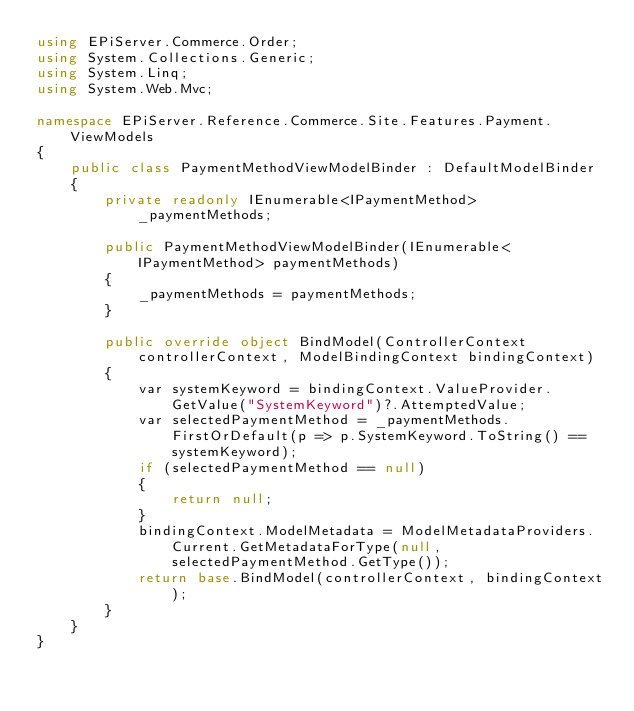Convert code to text. <code><loc_0><loc_0><loc_500><loc_500><_C#_>using EPiServer.Commerce.Order;
using System.Collections.Generic;
using System.Linq;
using System.Web.Mvc;

namespace EPiServer.Reference.Commerce.Site.Features.Payment.ViewModels
{
    public class PaymentMethodViewModelBinder : DefaultModelBinder
    {
        private readonly IEnumerable<IPaymentMethod> _paymentMethods;

        public PaymentMethodViewModelBinder(IEnumerable<IPaymentMethod> paymentMethods)
        {
            _paymentMethods = paymentMethods;
        }

        public override object BindModel(ControllerContext controllerContext, ModelBindingContext bindingContext)
        {
            var systemKeyword = bindingContext.ValueProvider.GetValue("SystemKeyword")?.AttemptedValue;
            var selectedPaymentMethod = _paymentMethods.FirstOrDefault(p => p.SystemKeyword.ToString() == systemKeyword);
            if (selectedPaymentMethod == null)
            {
                return null;
            }
            bindingContext.ModelMetadata = ModelMetadataProviders.Current.GetMetadataForType(null, selectedPaymentMethod.GetType());
            return base.BindModel(controllerContext, bindingContext);
        }
    }
}</code> 